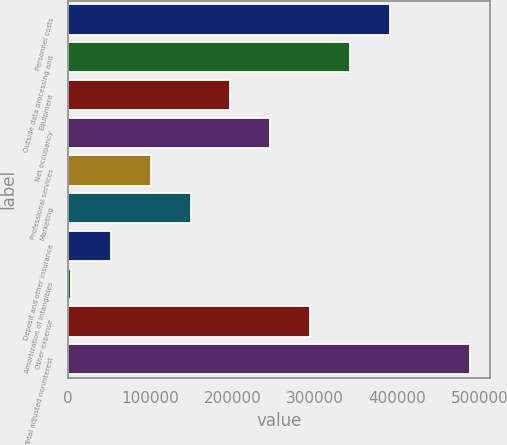Convert chart. <chart><loc_0><loc_0><loc_500><loc_500><bar_chart><fcel>Personnel costs<fcel>Outside data processing and<fcel>Equipment<fcel>Net occupancy<fcel>Professional services<fcel>Marketing<fcel>Deposit and other insurance<fcel>Amortization of intangibles<fcel>Other expense<fcel>Total adjusted noninterest<nl><fcel>391378<fcel>342930<fcel>197583<fcel>246032<fcel>100686<fcel>149134<fcel>52236.8<fcel>3788<fcel>294481<fcel>488276<nl></chart> 